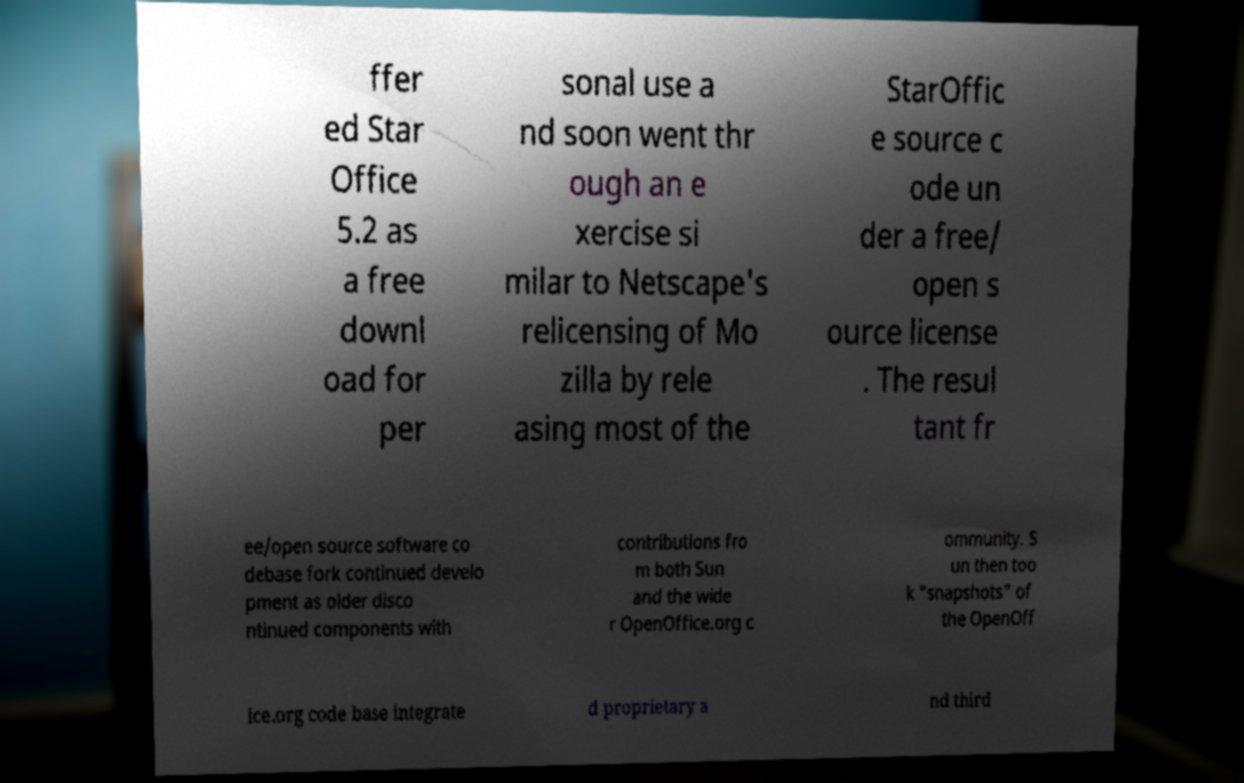For documentation purposes, I need the text within this image transcribed. Could you provide that? ffer ed Star Office 5.2 as a free downl oad for per sonal use a nd soon went thr ough an e xercise si milar to Netscape's relicensing of Mo zilla by rele asing most of the StarOffic e source c ode un der a free/ open s ource license . The resul tant fr ee/open source software co debase fork continued develo pment as older disco ntinued components with contributions fro m both Sun and the wide r OpenOffice.org c ommunity. S un then too k "snapshots" of the OpenOff ice.org code base integrate d proprietary a nd third 